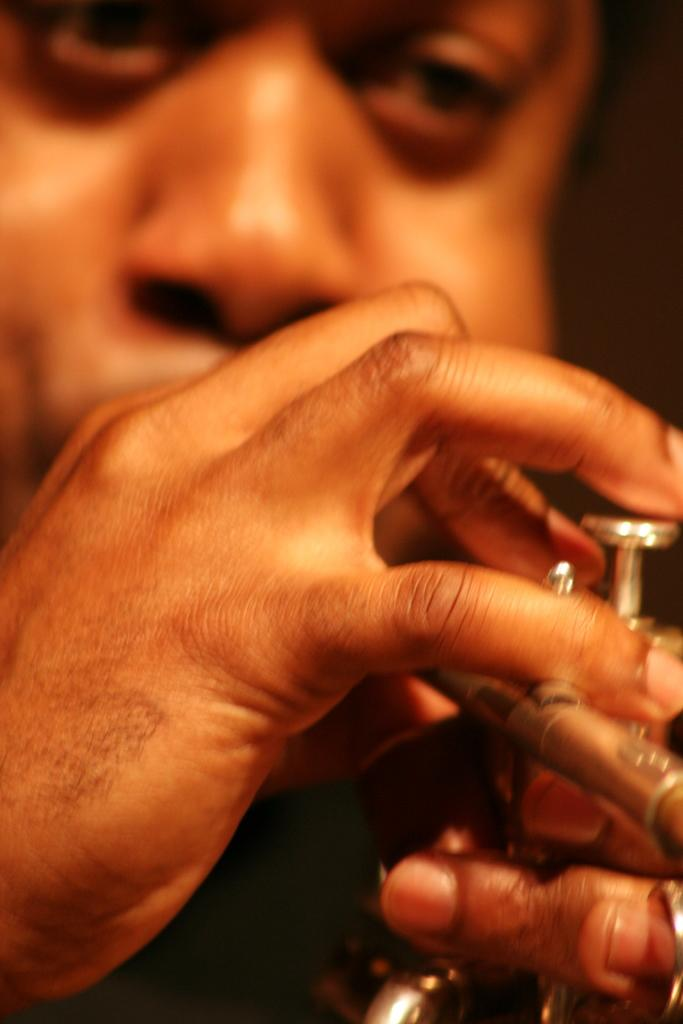What is the main subject of the image? The main subject of the image is a man. What is the man doing in the image? The man is playing a musical instrument in the image. What book is the man using as a whip in the image? There is no book or whip present in the image; the man is playing a musical instrument. 